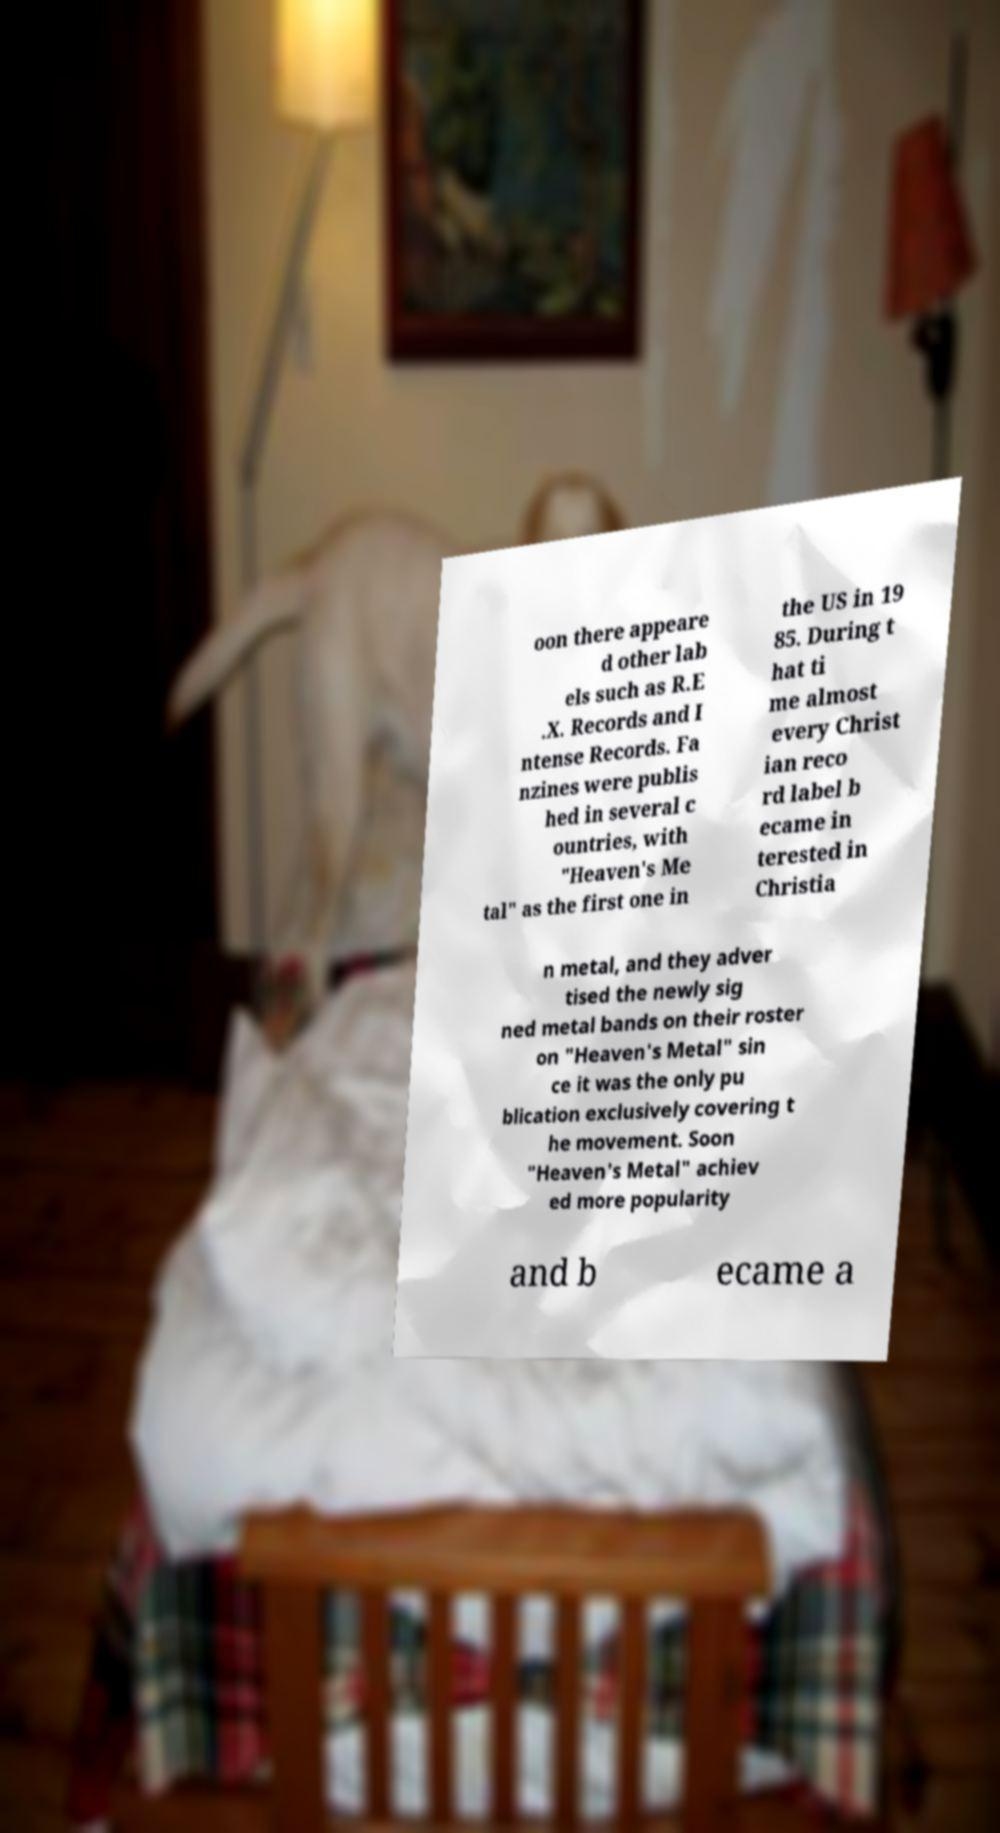Can you read and provide the text displayed in the image?This photo seems to have some interesting text. Can you extract and type it out for me? oon there appeare d other lab els such as R.E .X. Records and I ntense Records. Fa nzines were publis hed in several c ountries, with "Heaven's Me tal" as the first one in the US in 19 85. During t hat ti me almost every Christ ian reco rd label b ecame in terested in Christia n metal, and they adver tised the newly sig ned metal bands on their roster on "Heaven's Metal" sin ce it was the only pu blication exclusively covering t he movement. Soon "Heaven's Metal" achiev ed more popularity and b ecame a 